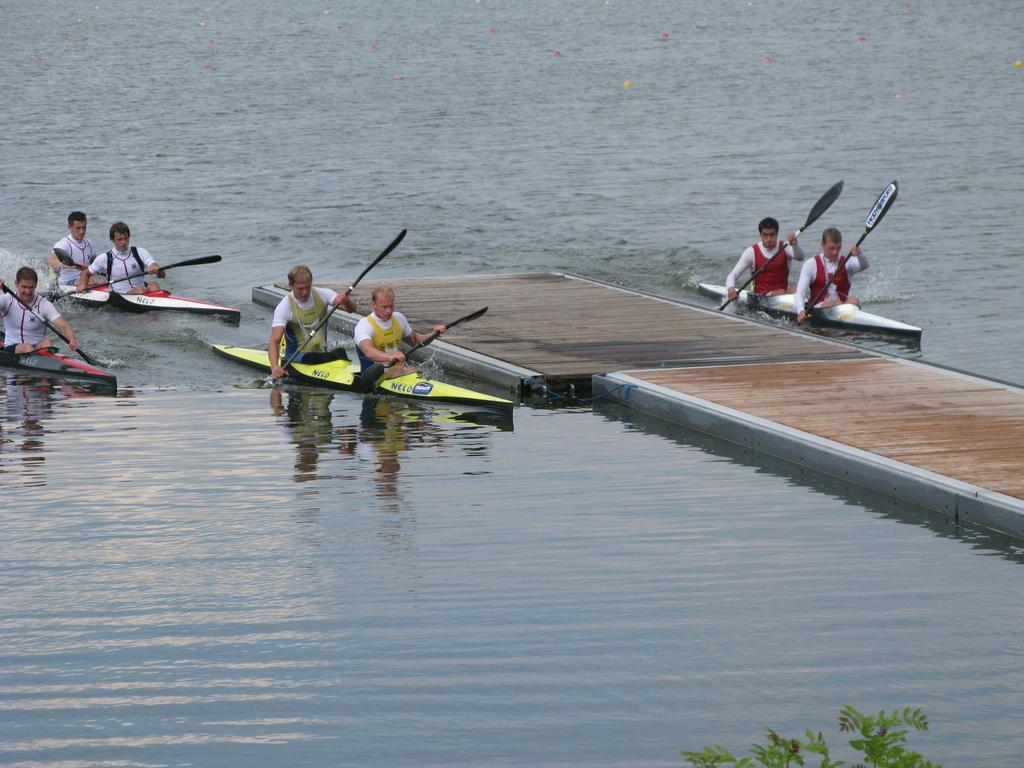How would you summarize this image in a sentence or two? This is the picture of a river in which there is a bridge and some people rowing in it. 